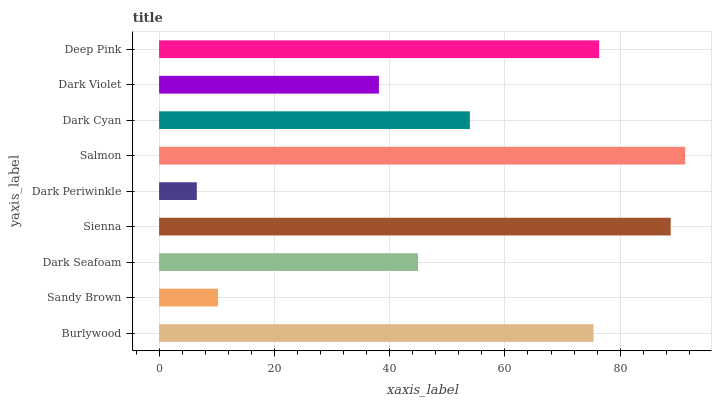Is Dark Periwinkle the minimum?
Answer yes or no. Yes. Is Salmon the maximum?
Answer yes or no. Yes. Is Sandy Brown the minimum?
Answer yes or no. No. Is Sandy Brown the maximum?
Answer yes or no. No. Is Burlywood greater than Sandy Brown?
Answer yes or no. Yes. Is Sandy Brown less than Burlywood?
Answer yes or no. Yes. Is Sandy Brown greater than Burlywood?
Answer yes or no. No. Is Burlywood less than Sandy Brown?
Answer yes or no. No. Is Dark Cyan the high median?
Answer yes or no. Yes. Is Dark Cyan the low median?
Answer yes or no. Yes. Is Sienna the high median?
Answer yes or no. No. Is Burlywood the low median?
Answer yes or no. No. 